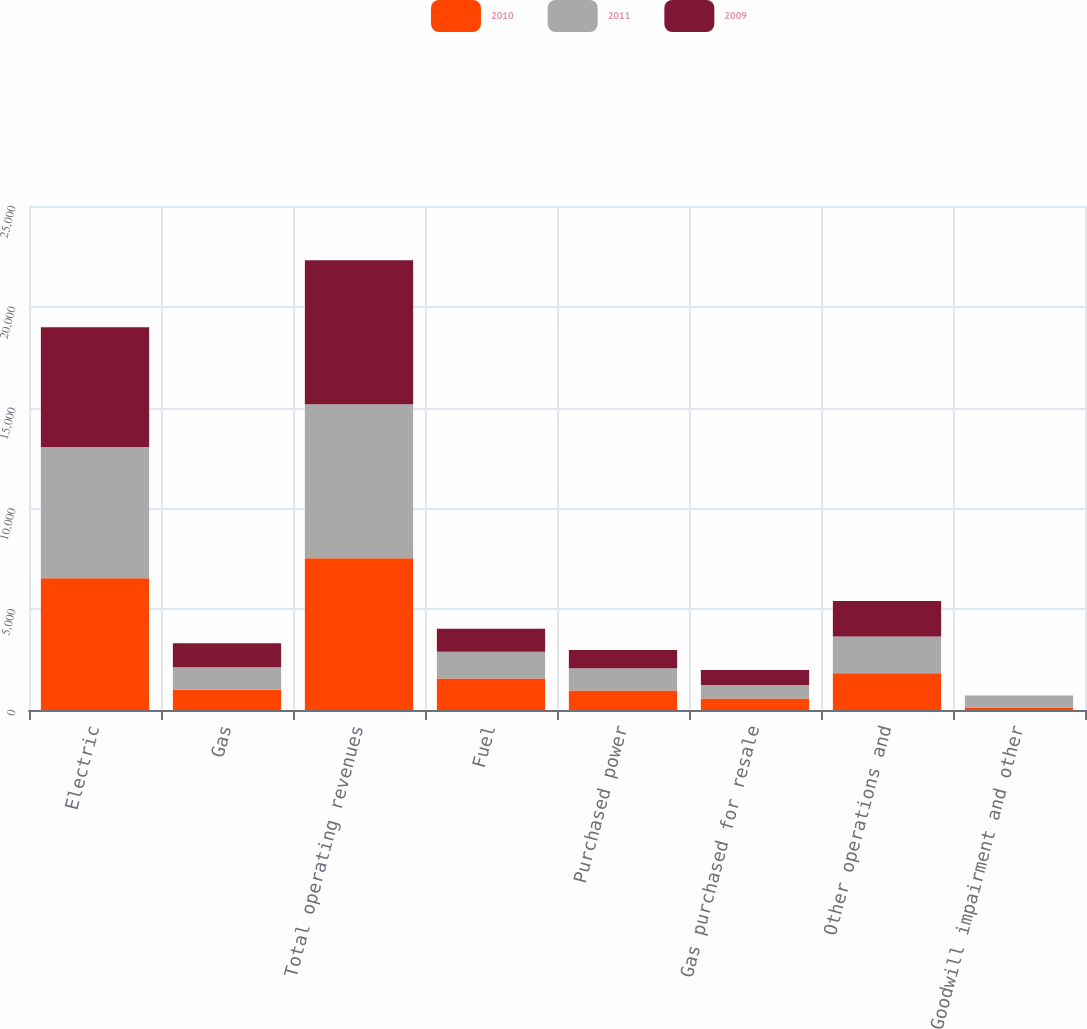Convert chart to OTSL. <chart><loc_0><loc_0><loc_500><loc_500><stacked_bar_chart><ecel><fcel>Electric<fcel>Gas<fcel>Total operating revenues<fcel>Fuel<fcel>Purchased power<fcel>Gas purchased for resale<fcel>Other operations and<fcel>Goodwill impairment and other<nl><fcel>2010<fcel>6530<fcel>1001<fcel>7531<fcel>1567<fcel>966<fcel>570<fcel>1820<fcel>125<nl><fcel>2011<fcel>6521<fcel>1117<fcel>7638<fcel>1323<fcel>1106<fcel>669<fcel>1821<fcel>589<nl><fcel>2009<fcel>5940<fcel>1195<fcel>7135<fcel>1141<fcel>909<fcel>749<fcel>1768<fcel>7<nl></chart> 